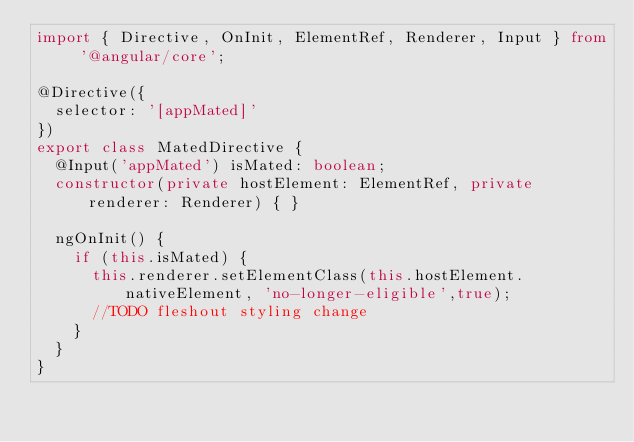<code> <loc_0><loc_0><loc_500><loc_500><_TypeScript_>import { Directive, OnInit, ElementRef, Renderer, Input } from '@angular/core';

@Directive({
  selector: '[appMated]'
})
export class MatedDirective {
  @Input('appMated') isMated: boolean;
  constructor(private hostElement: ElementRef, private renderer: Renderer) { }

  ngOnInit() {
    if (this.isMated) {
      this.renderer.setElementClass(this.hostElement.nativeElement, 'no-longer-eligible',true);
      //TODO fleshout styling change
    }
  }
}
</code> 